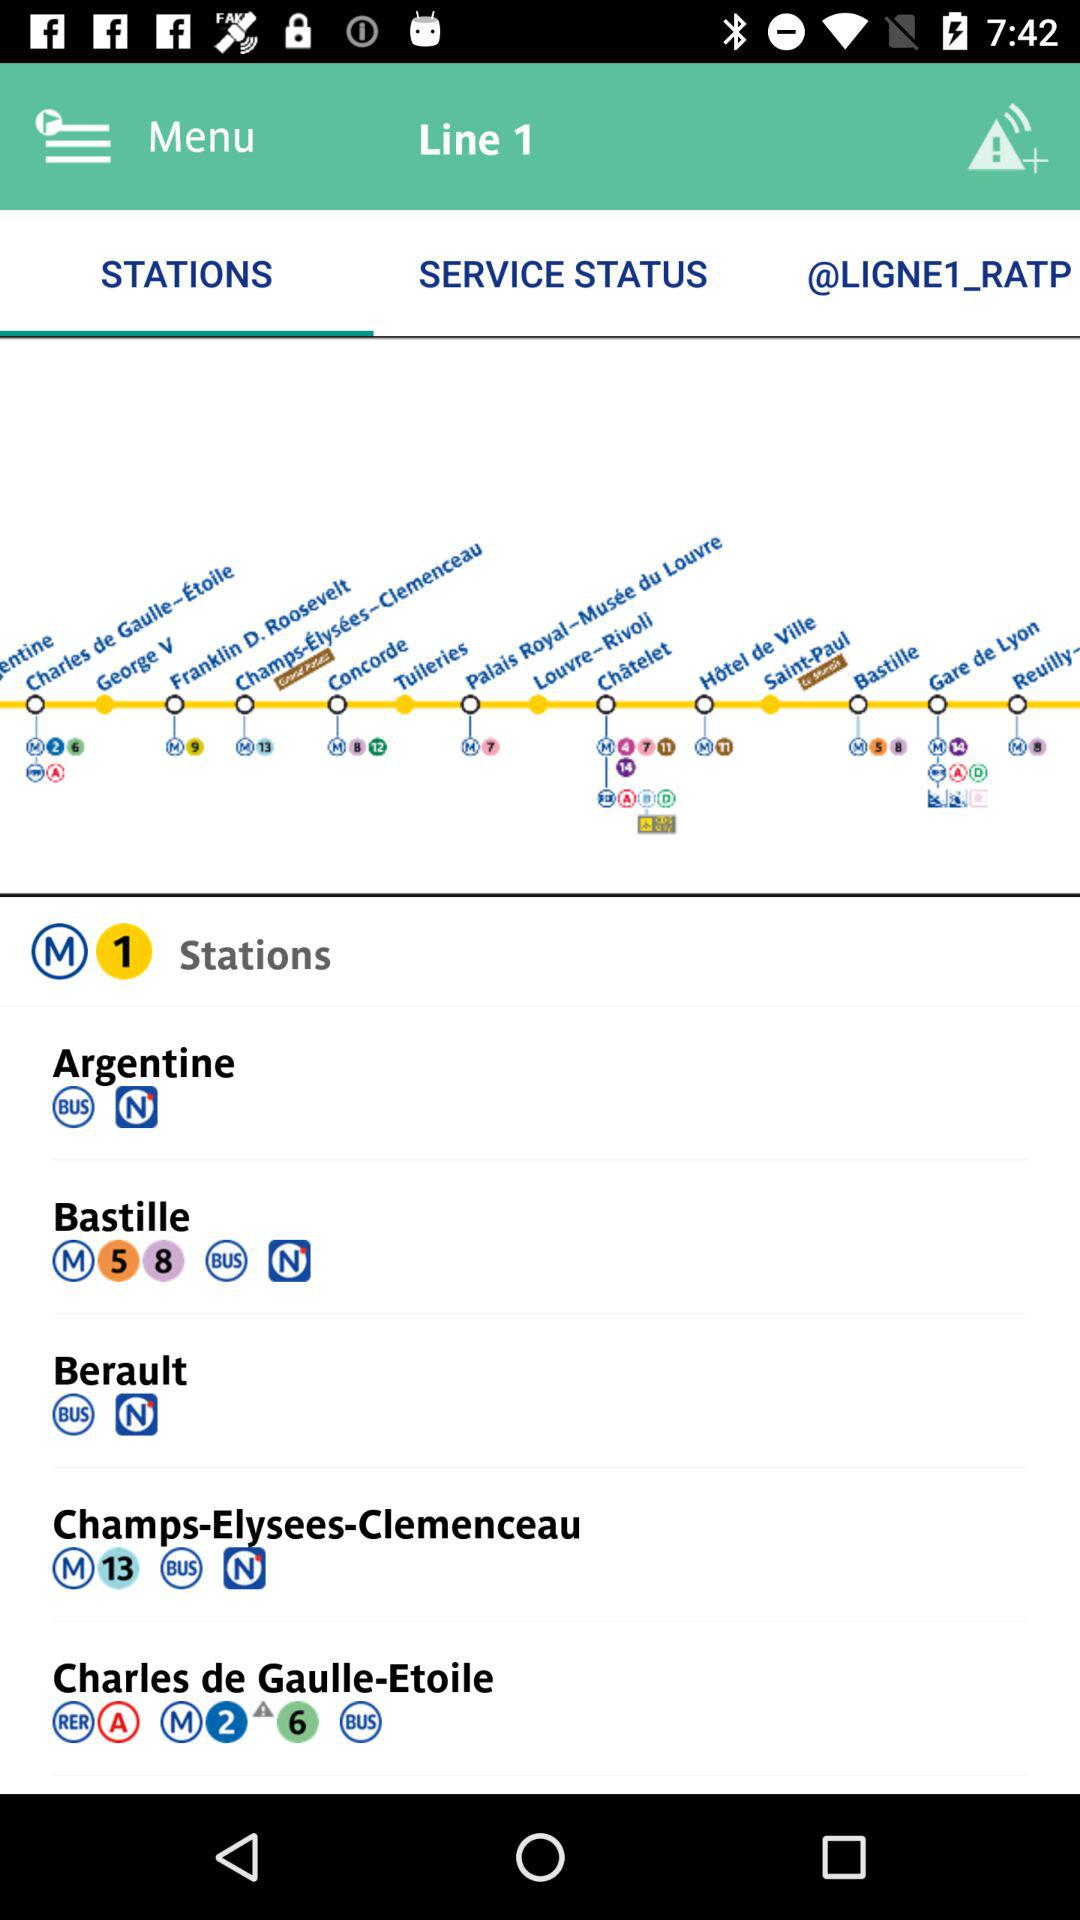Which tab is selected? The selected tab is "STATIONS". 